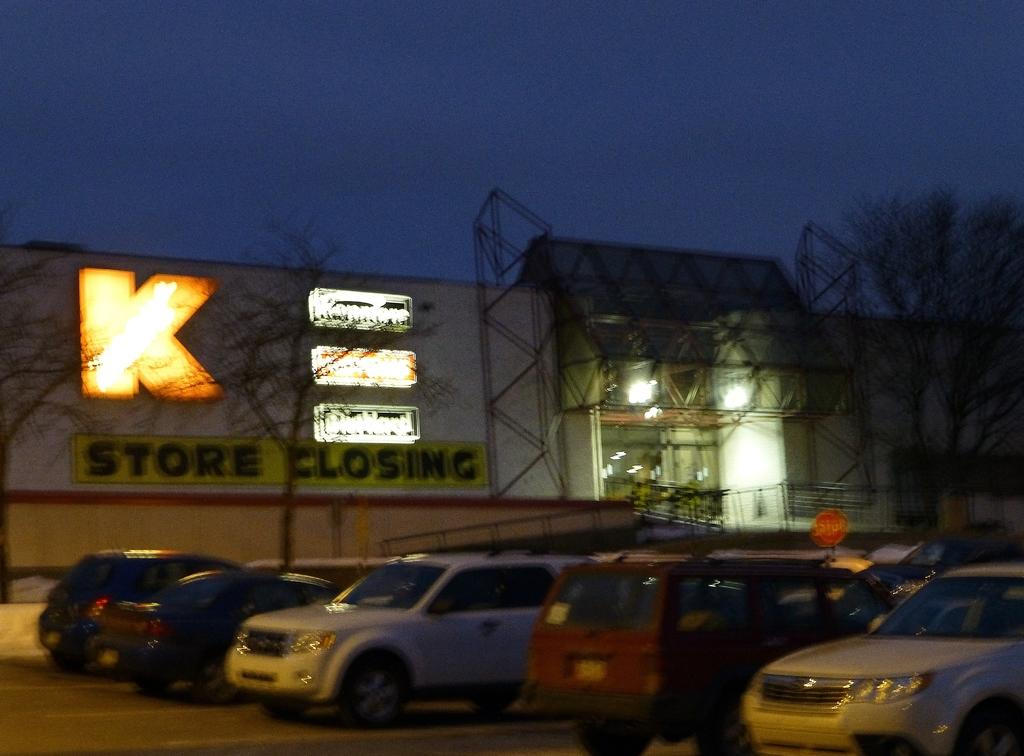<image>
Offer a succinct explanation of the picture presented. a store that has the letter K on it 